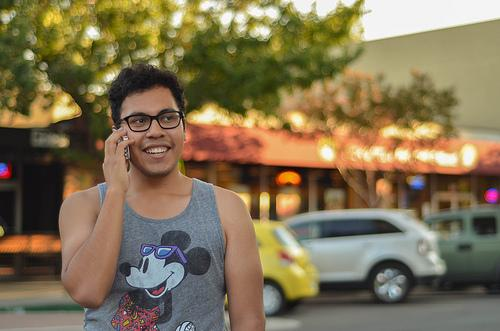Describe the different types of vehicles that can be seen in the background of the image. In the background, there is a white station wagon type car, a bright yellow car, and a large white SUV. What kind of location does the image seem to be taken in? The image seems to be taken in a place with a strip mall of businesses, paved street and trees in the background. Mention the type of phone the man is using and what he is doing with it. The man is using a cell phone and talking on it outdoors. Provide a general description of the image. The image shows a smiling black-haired man wearing a Mickey Mouse tank top and hipster eyeglasses, talking on his cell phone outdoors with cars and businesses in the background. Can you identify the character on the man's shirt? Mention any special feature of the character if any. The character on the man's shirt is Mickey Mouse, wearing purple sunglasses. What is the most prominent aspect of the man's outfit? The most prominent aspect of the man's outfit is his Disney tank top featuring Mickey Mouse with sunglasses. Briefly describe the man's physical appearance and what he is wearing. The man has messy dark brown hair, straight teeth, and black hipster eyeglasses. He is wearing a grey tank top with a Mickey Mouse logo. Count the number of cars visible in the image. Three cars are visible in the image: a white station wagon, a bright yellow car, and a large white SUV. Describe the type of eyeglasses the man is wearing. The man is wearing nerdy, black-framed hipster eyeglasses. Can you find a bicycle leaning against the tree in the background? No, it's not mentioned in the image. 